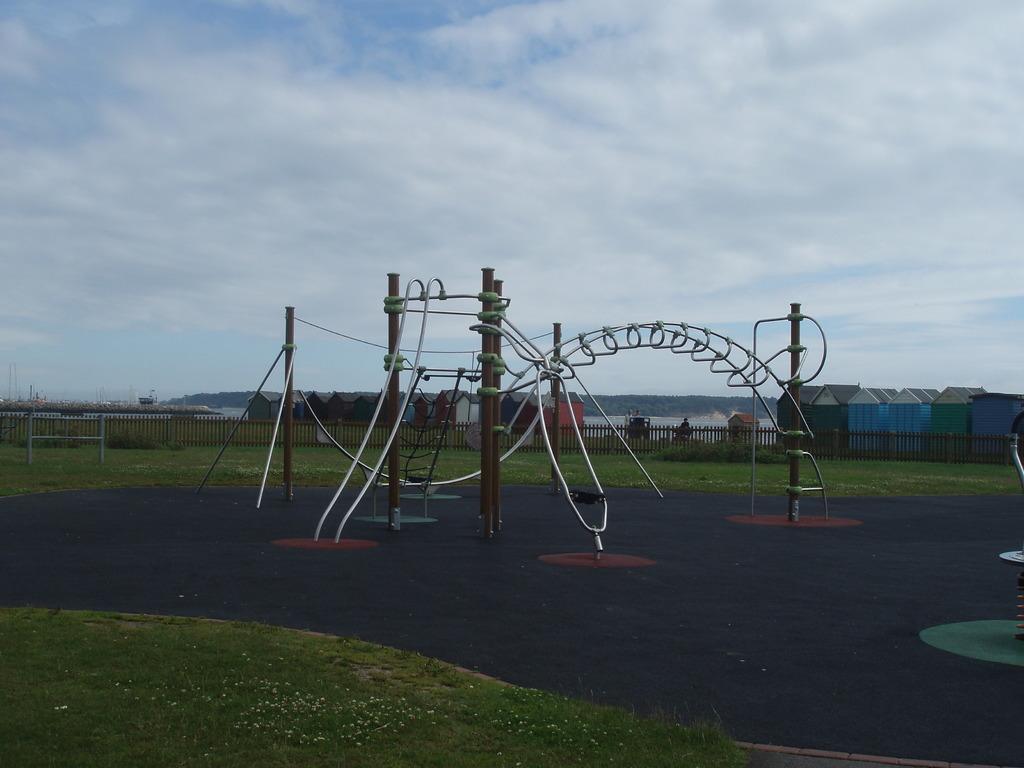How would you summarize this image in a sentence or two? In this picture I can see houses, fence, grass, plants, water, hills, there is a structure made up of poles and metal pipes, and in the background there is sky. 